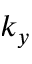Convert formula to latex. <formula><loc_0><loc_0><loc_500><loc_500>k _ { y }</formula> 